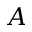Convert formula to latex. <formula><loc_0><loc_0><loc_500><loc_500>A</formula> 